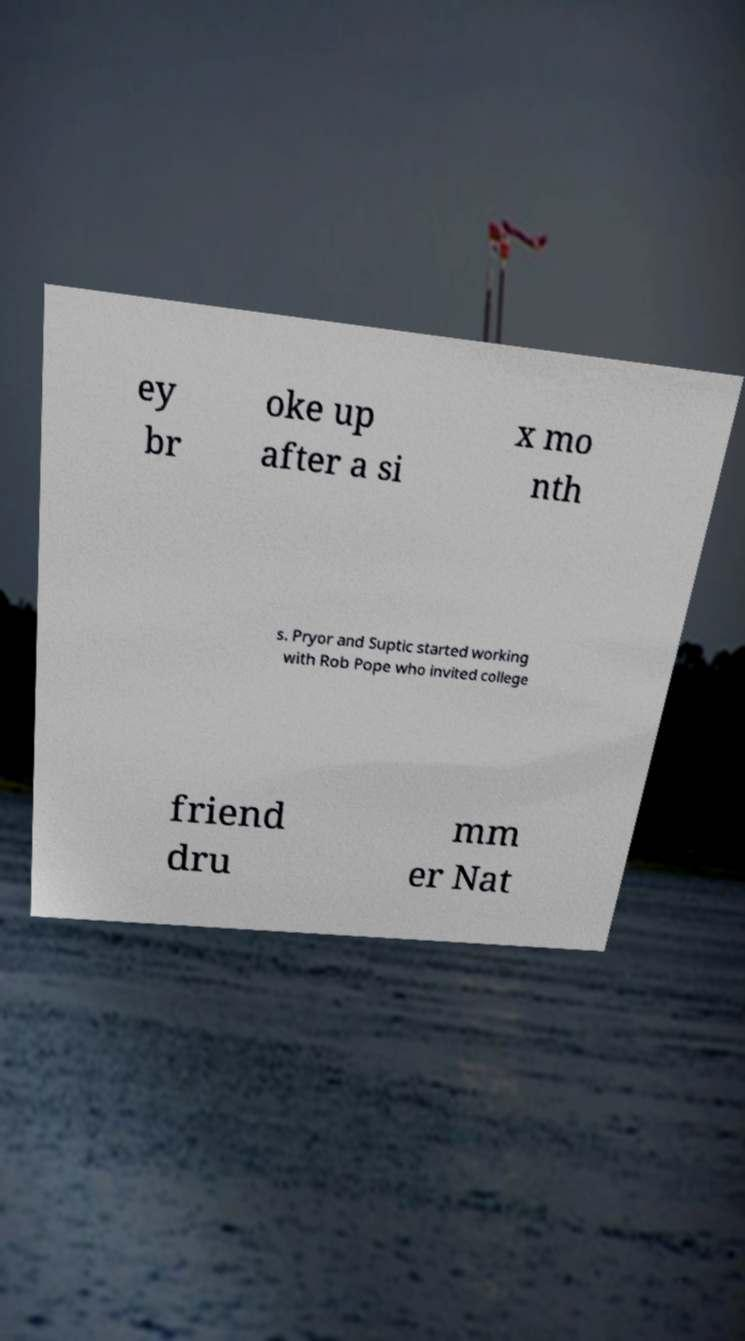Please read and relay the text visible in this image. What does it say? ey br oke up after a si x mo nth s. Pryor and Suptic started working with Rob Pope who invited college friend dru mm er Nat 